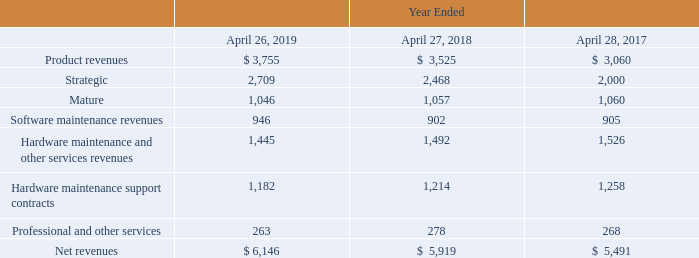Disaggregation of revenue
To provide visibility into our transition from older products to our newer, higher growth products and clarity into the dynamics of our product revenue, we have historically grouped our products by “Strategic” and “Mature” solutions. Strategic solutions include Clustered ONTAP, branded E-Series, SolidFire, converged and hyper-converged infrastructure, ELAs and other optional add-on software products. Mature solutions include 7-mode ONTAP, add-on hardware and related operating system (OS) software and original equipment manufacturers (OEM) products. Both our Mature and Strategic product lines include a mix of disk, hybrid and all flash storage media. Additionally, we provide a variety of services including software maintenance, hardware maintenance and other services including professional services, global support solutions, and customer education and training.
The following table depicts the disaggregation of revenue by our products and services (in millions):
Revenues by geographic region are presented in Note 16 – Segment, Geographic, and Significant Customer Information
Which years does the table provide information for the disaggregation of revenue by the company's products and services for? 2019, 2018, 2017. What does both the company's Mature and Strategic product lines include? A mix of disk, hybrid and all flash storage media. What were the product revenues in 2019?
Answer scale should be: million. 3,755. What was the change in the company's product revenue between 2017 and 2018?
Answer scale should be: million. 3,525-3,060
Answer: 465. How many years did revenue from mature product lines exceed $1,000 million? 2019##2018##2017
Answer: 3. What was the percentage change in net revenues between 2018 and 2019?
Answer scale should be: percent. (6,146-5,919)/5,919
Answer: 3.84. 